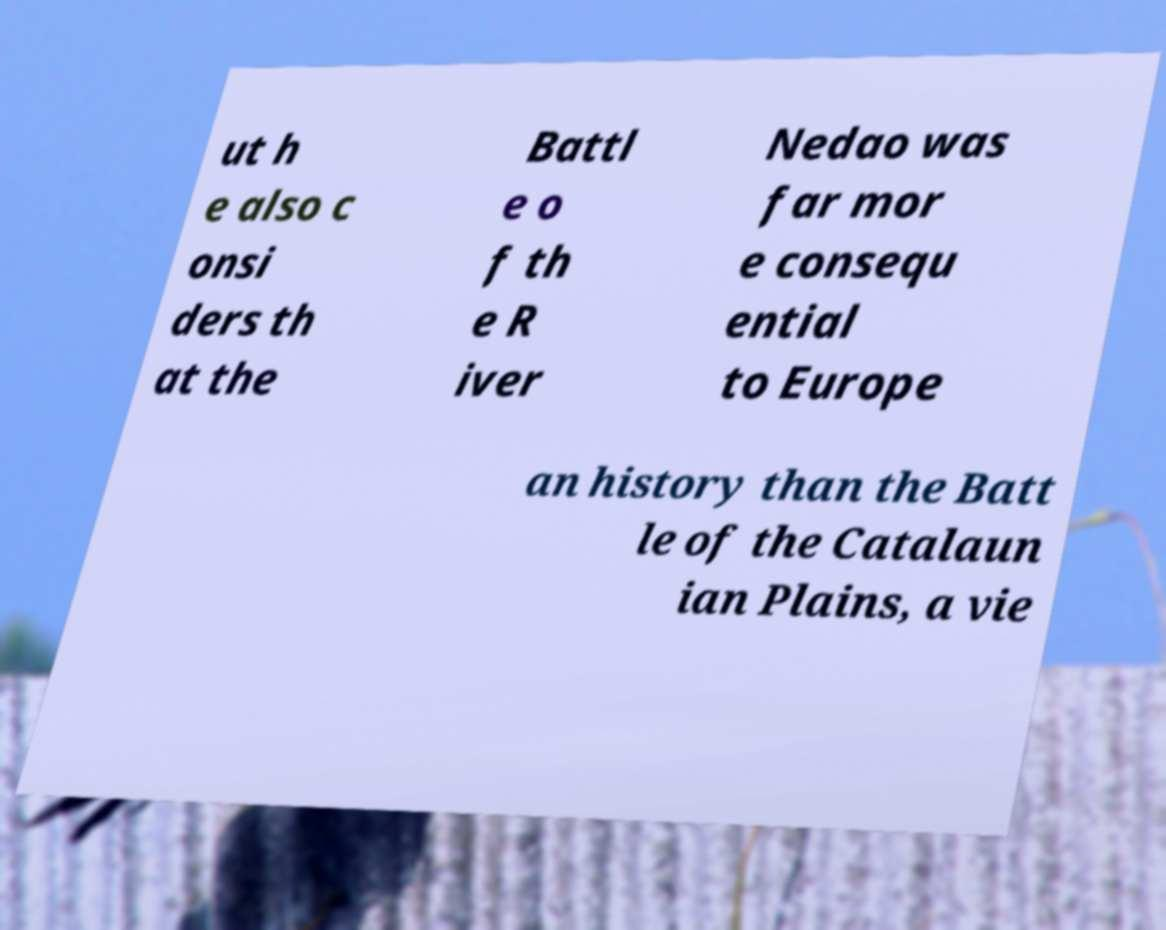What messages or text are displayed in this image? I need them in a readable, typed format. ut h e also c onsi ders th at the Battl e o f th e R iver Nedao was far mor e consequ ential to Europe an history than the Batt le of the Catalaun ian Plains, a vie 